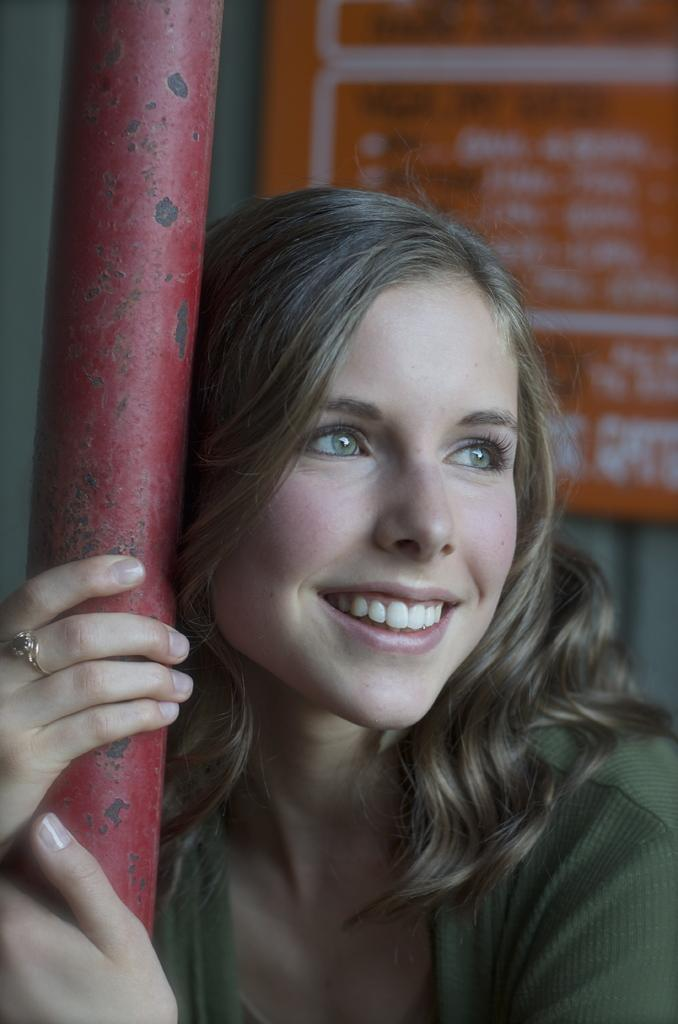What can be seen in the background of the image? There is a board in the background of the image. Who is present in the image? There is a woman in the image. What is the woman holding in her hands? The woman is holding a red pole in her hands. Can you describe any accessories the woman is wearing? The woman has a ring on her finger. What type of hat is the woman wearing in the image? There is no hat visible in the image. What kind of wood is the red pole made of in the image? The facts provided do not mention the material of the red pole, so it cannot be determined from the image. 